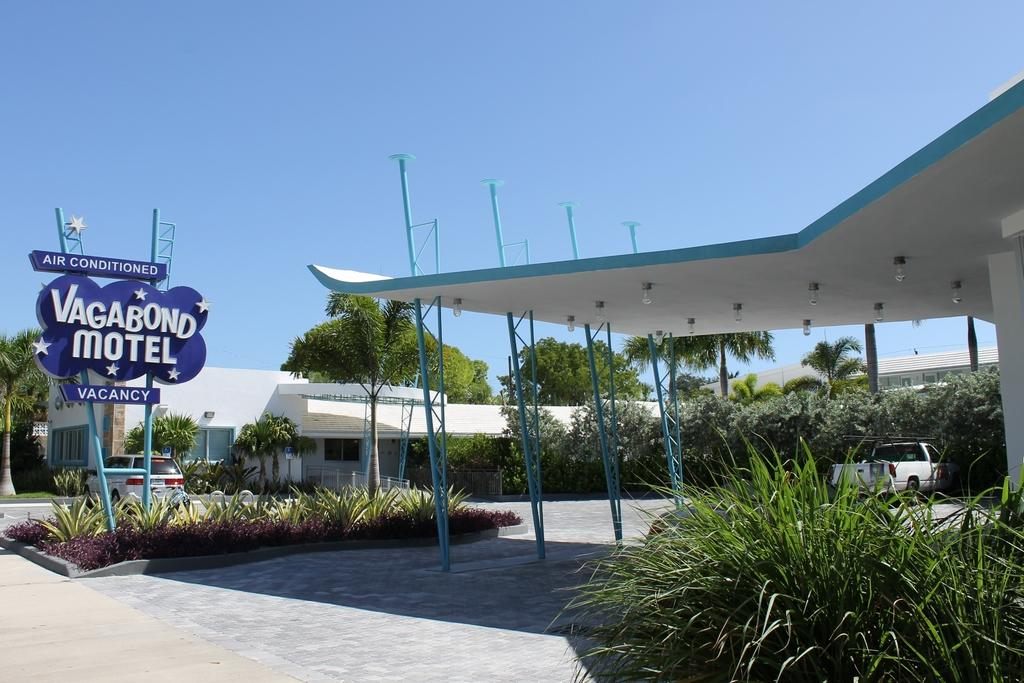<image>
Share a concise interpretation of the image provided. Vagabond Motel with air conditioned and a white truck parked there 